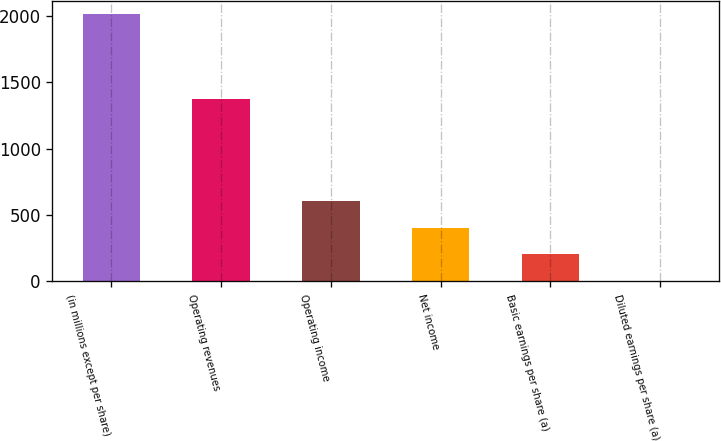Convert chart to OTSL. <chart><loc_0><loc_0><loc_500><loc_500><bar_chart><fcel>(in millions except per share)<fcel>Operating revenues<fcel>Operating income<fcel>Net income<fcel>Basic earnings per share (a)<fcel>Diluted earnings per share (a)<nl><fcel>2015<fcel>1377<fcel>605.56<fcel>404.21<fcel>202.86<fcel>1.51<nl></chart> 